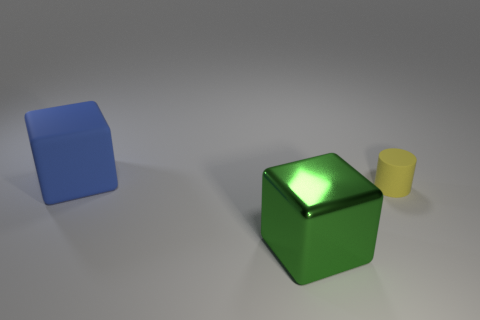There is a thing that is behind the tiny thing; how big is it?
Offer a very short reply. Large. Are there more small yellow objects right of the green thing than tiny red objects?
Your response must be concise. Yes. What shape is the tiny thing?
Provide a succinct answer. Cylinder. Does the large green metallic thing have the same shape as the blue thing?
Provide a succinct answer. Yes. Is there anything else that has the same shape as the yellow object?
Make the answer very short. No. Do the big thing that is in front of the cylinder and the small yellow thing have the same material?
Your answer should be very brief. No. There is a thing that is behind the green shiny object and to the left of the yellow thing; what is its shape?
Provide a short and direct response. Cube. Is there a big shiny cube to the right of the big thing to the right of the matte cube?
Your answer should be very brief. No. How many other things are made of the same material as the green cube?
Your response must be concise. 0. Is the shape of the thing on the left side of the large green block the same as the big object in front of the tiny object?
Offer a very short reply. Yes. 